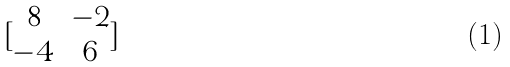<formula> <loc_0><loc_0><loc_500><loc_500>[ \begin{matrix} 8 & - 2 \\ - 4 & 6 \end{matrix} ]</formula> 